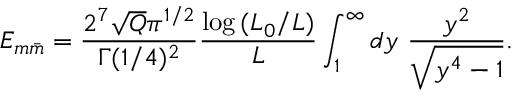<formula> <loc_0><loc_0><loc_500><loc_500>E _ { m \bar { m } } = { \frac { 2 ^ { 7 } \sqrt { Q } \pi ^ { 1 / 2 } } { \Gamma ( 1 / 4 ) ^ { 2 } } } { \frac { \log { ( L _ { 0 } / L ) } } { L } } \int _ { 1 } ^ { \infty } d y \ { \frac { y ^ { 2 } } { \sqrt { y ^ { 4 } - 1 } } } .</formula> 